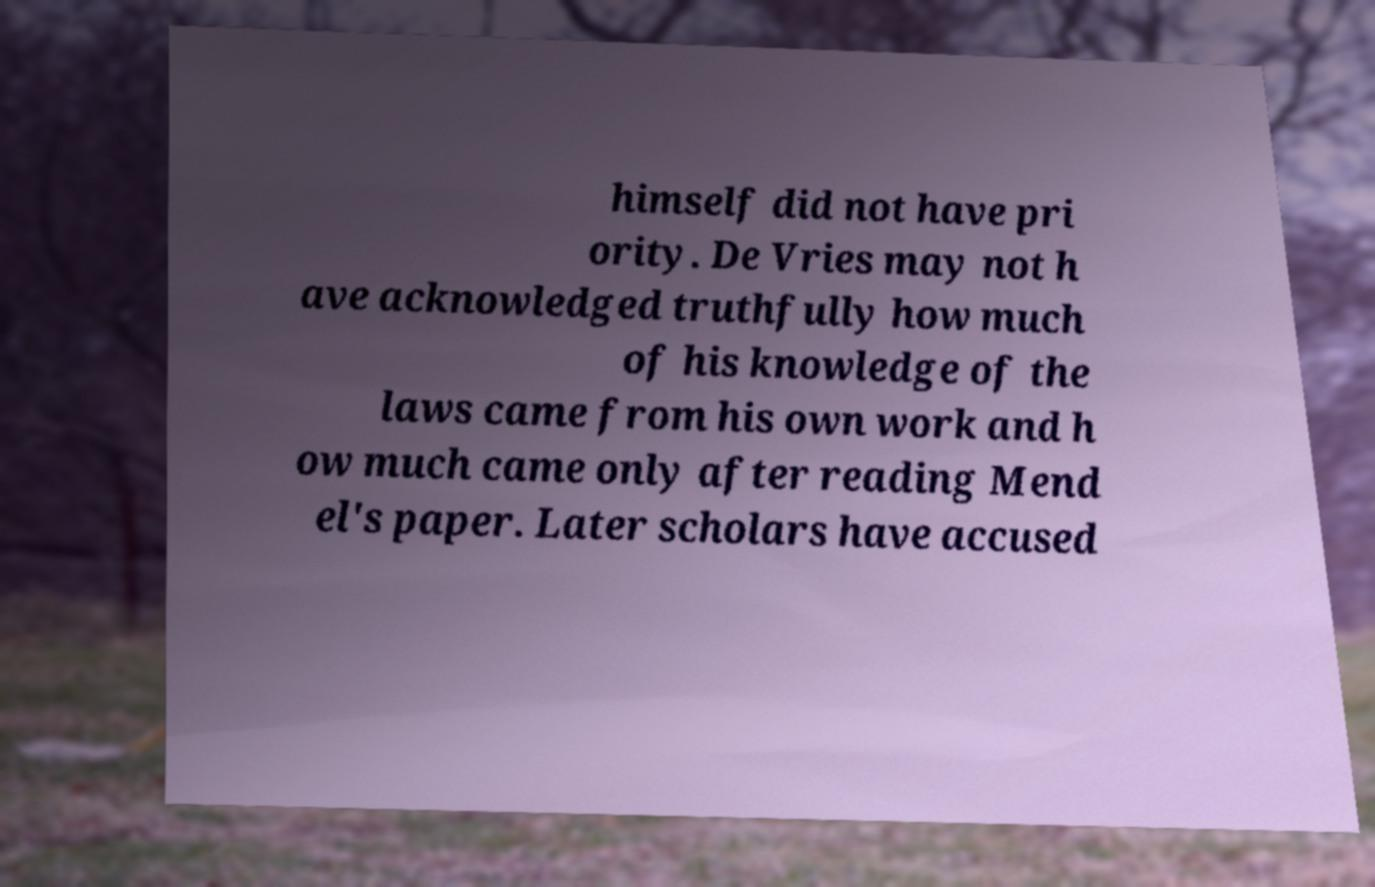There's text embedded in this image that I need extracted. Can you transcribe it verbatim? himself did not have pri ority. De Vries may not h ave acknowledged truthfully how much of his knowledge of the laws came from his own work and h ow much came only after reading Mend el's paper. Later scholars have accused 